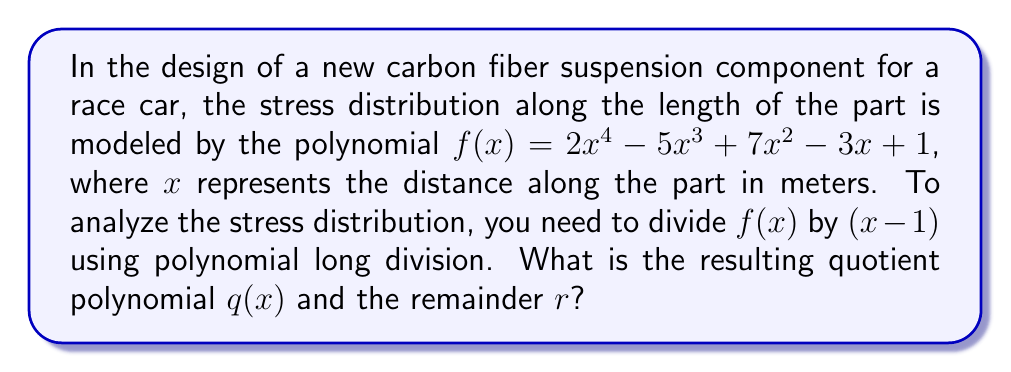Help me with this question. Let's perform polynomial long division of $f(x)$ by $(x - 1)$:

$$
\begin{array}{r}
2x^3 + 3x^2 + 10x + 7 \\
x - 1 \enclose{longdiv}{2x^4 - 5x^3 + 7x^2 - 3x + 1} \\
\underline{2x^4 - 2x^3} \\
-3x^3 + 7x^2 \\
\underline{-3x^3 + 3x^2} \\
4x^2 - 3x \\
\underline{4x^2 - 4x} \\
x + 1 \\
\underline{x - 1} \\
2
\end{array}
$$

Step 1: Divide $2x^4$ by $x$ to get $2x^3$. Multiply $(x - 1)$ by $2x^3$ and subtract from $f(x)$.

Step 2: Bring down the next term. Divide $-3x^3$ by $x$ to get $-3x^2$. Multiply $(x - 1)$ by $-3x^2$ and subtract.

Step 3: Bring down the next term. Divide $4x^2$ by $x$ to get $4x$. Multiply $(x - 1)$ by $4x$ and subtract.

Step 4: Bring down the next term. Divide $x$ by $x$ to get $1$. Multiply $(x - 1)$ by $1$ and subtract.

Step 5: The process ends here as the degree of the remainder (2) is less than the degree of the divisor $(x - 1)$.

Therefore, the quotient polynomial $q(x) = 2x^3 + 3x^2 + 10x + 7$, and the remainder $r = 2$.

This means that $f(x) = (x - 1)(2x^3 + 3x^2 + 10x + 7) + 2$.
Answer: Quotient polynomial: $q(x) = 2x^3 + 3x^2 + 10x + 7$
Remainder: $r = 2$ 